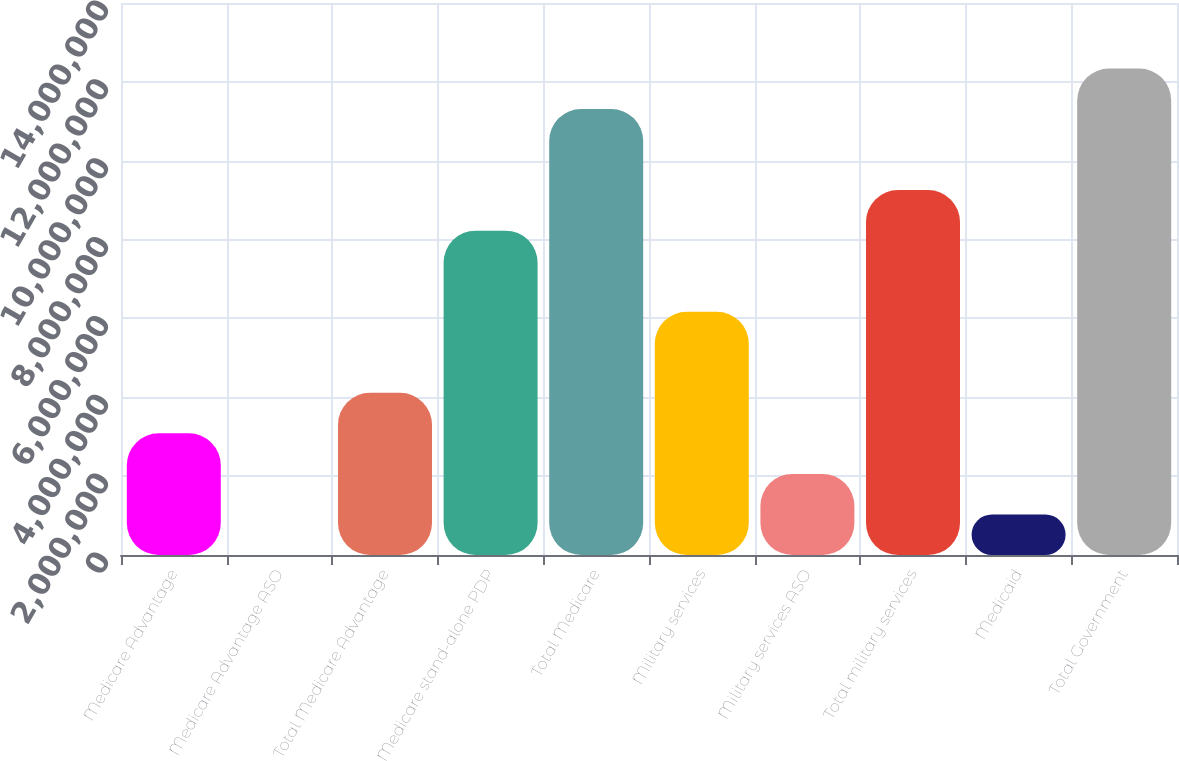<chart> <loc_0><loc_0><loc_500><loc_500><bar_chart><fcel>Medicare Advantage<fcel>Medicare Advantage ASO<fcel>Total Medicare Advantage<fcel>Medicare stand-alone PDP<fcel>Total Medicare<fcel>Military services<fcel>Military services ASO<fcel>Total military services<fcel>Medicaid<fcel>Total Government<nl><fcel>3.08499e+06<fcel>1.84<fcel>4.11332e+06<fcel>8.22664e+06<fcel>1.13116e+07<fcel>6.16998e+06<fcel>2.05666e+06<fcel>9.25497e+06<fcel>1.02833e+06<fcel>1.234e+07<nl></chart> 